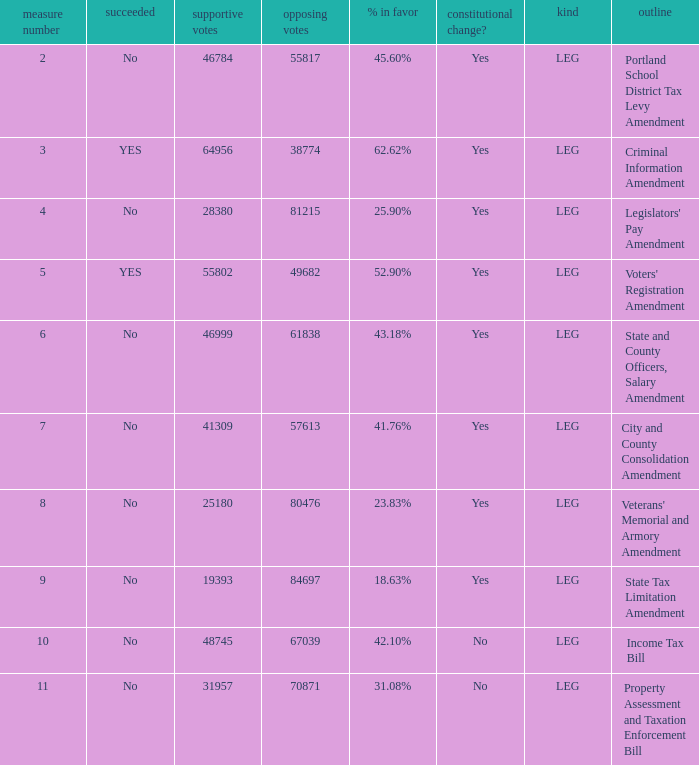How many yes votes made up 43.18% yes? 46999.0. 